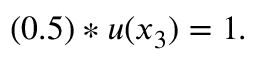Convert formula to latex. <formula><loc_0><loc_0><loc_500><loc_500>( 0 . 5 ) * u ( x _ { 3 } ) = 1 .</formula> 